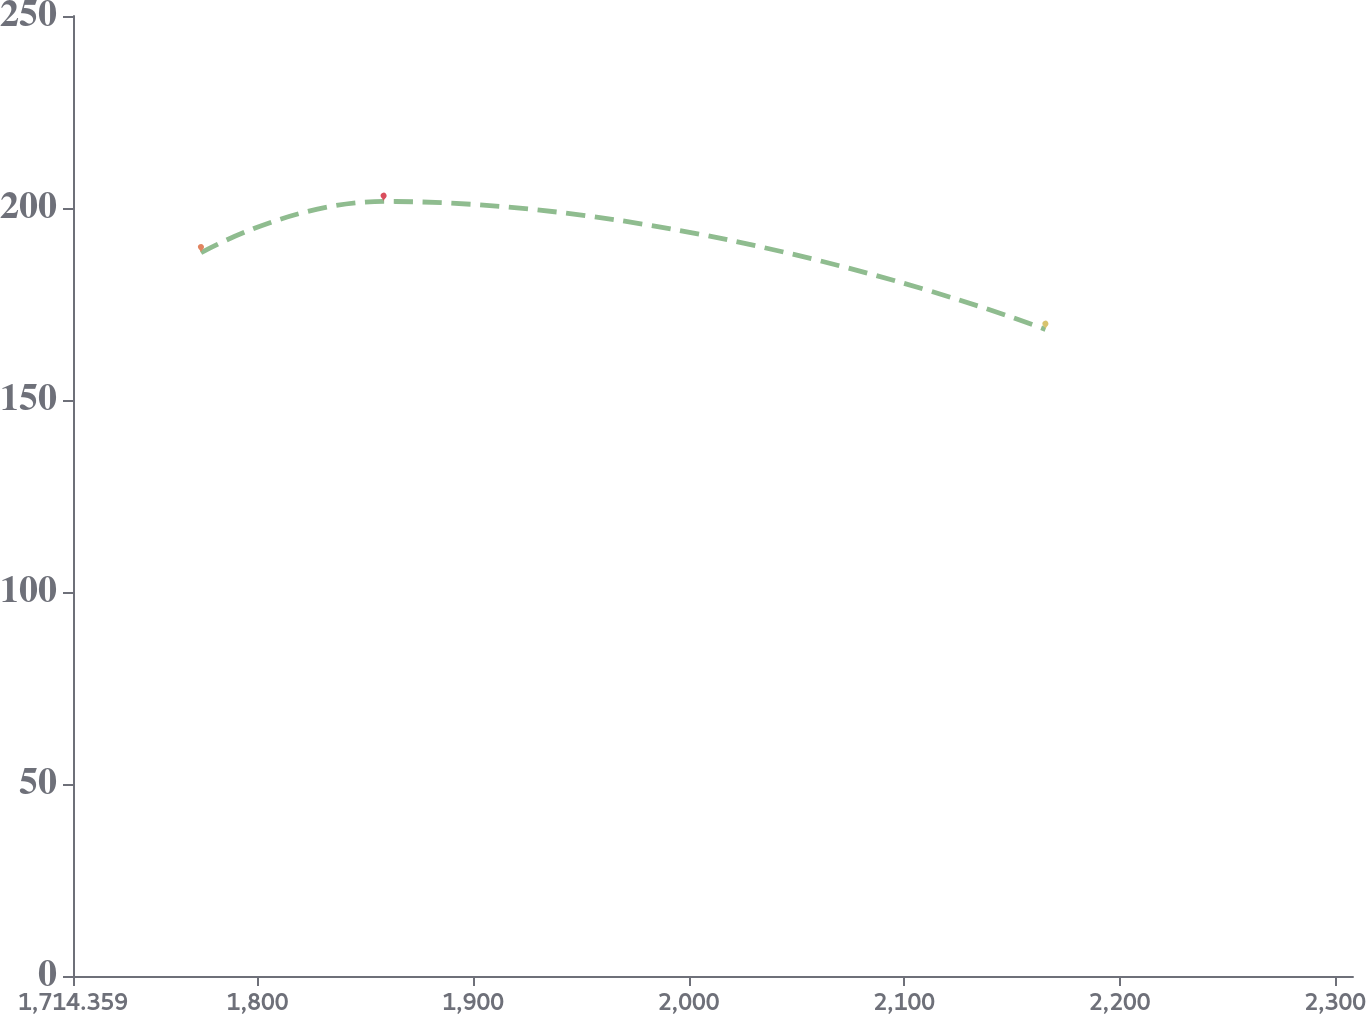Convert chart. <chart><loc_0><loc_0><loc_500><loc_500><line_chart><ecel><fcel>Unnamed: 1<nl><fcel>1773.75<fcel>188.34<nl><fcel>1858.5<fcel>201.71<nl><fcel>2165.57<fcel>168.39<nl><fcel>2310.98<fcel>142.33<nl><fcel>2367.66<fcel>194.28<nl></chart> 